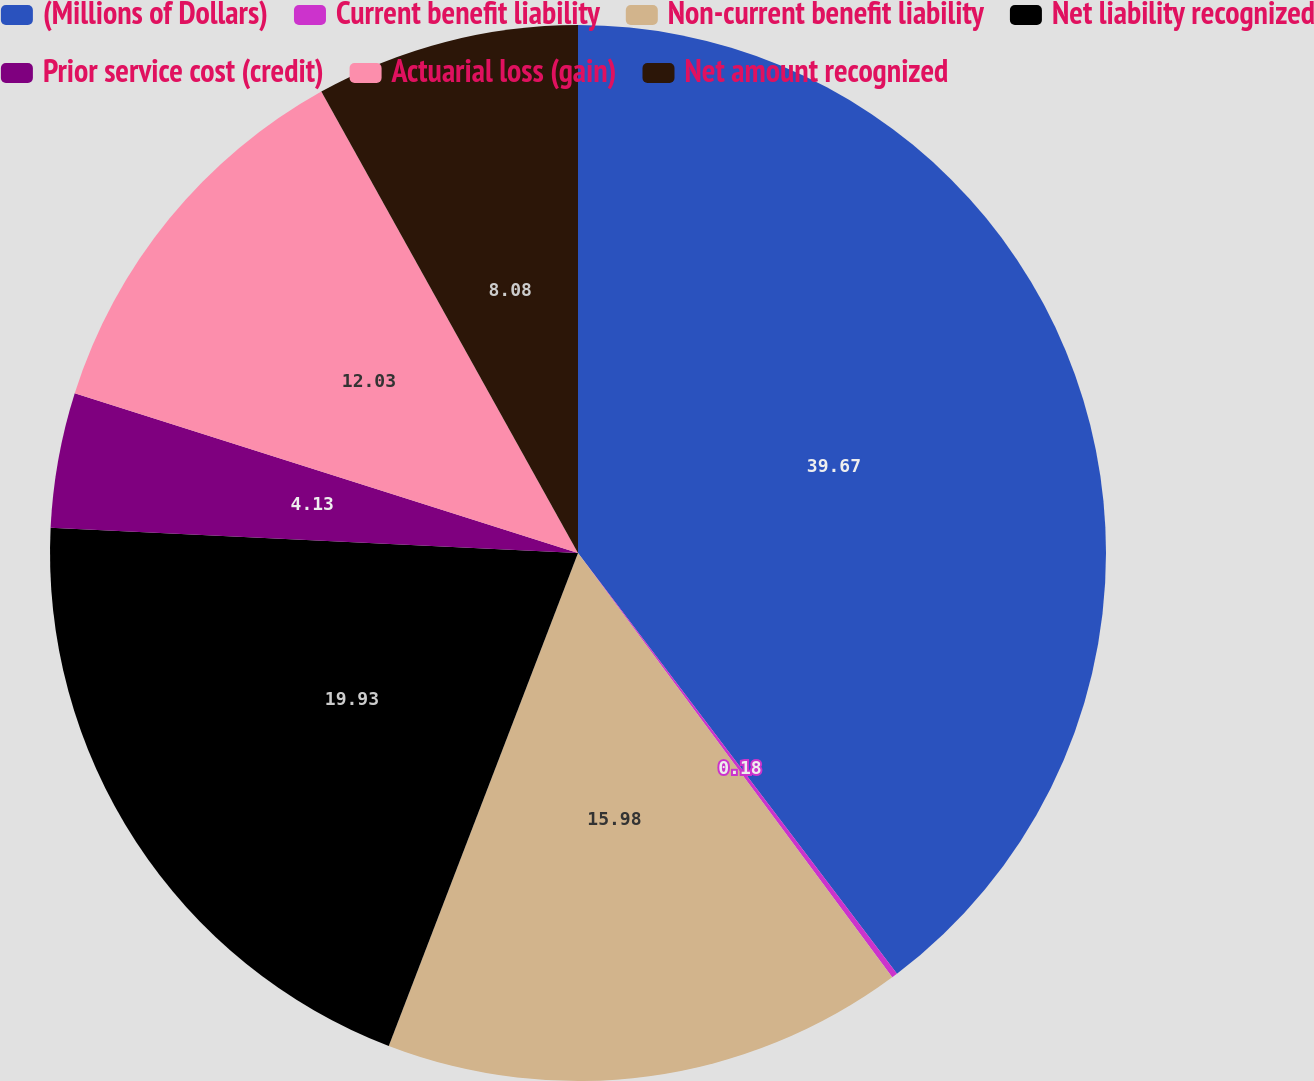Convert chart to OTSL. <chart><loc_0><loc_0><loc_500><loc_500><pie_chart><fcel>(Millions of Dollars)<fcel>Current benefit liability<fcel>Non-current benefit liability<fcel>Net liability recognized<fcel>Prior service cost (credit)<fcel>Actuarial loss (gain)<fcel>Net amount recognized<nl><fcel>39.68%<fcel>0.18%<fcel>15.98%<fcel>19.93%<fcel>4.13%<fcel>12.03%<fcel>8.08%<nl></chart> 